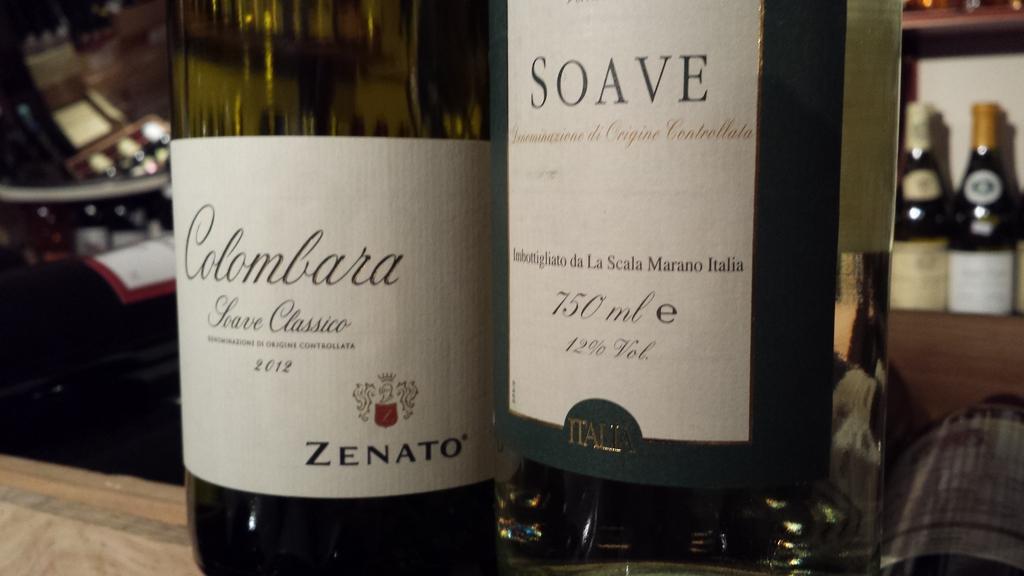What is the bottle on the left?
Ensure brevity in your answer.  Colombara. What is the brand of the wine on the left?
Provide a short and direct response. Colombara. 